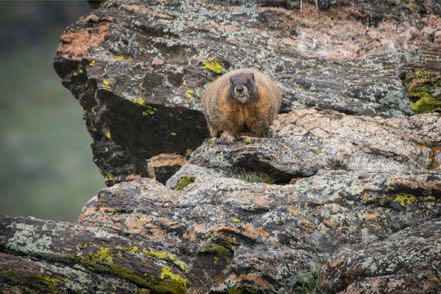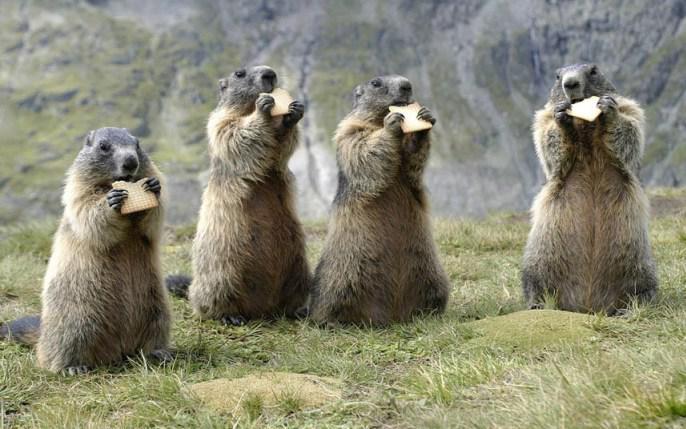The first image is the image on the left, the second image is the image on the right. Analyze the images presented: Is the assertion "Two marmots are in contact in a nuzzling pose in one image." valid? Answer yes or no. No. The first image is the image on the left, the second image is the image on the right. Considering the images on both sides, is "there are at least two animals eating in the image on the right." valid? Answer yes or no. Yes. 